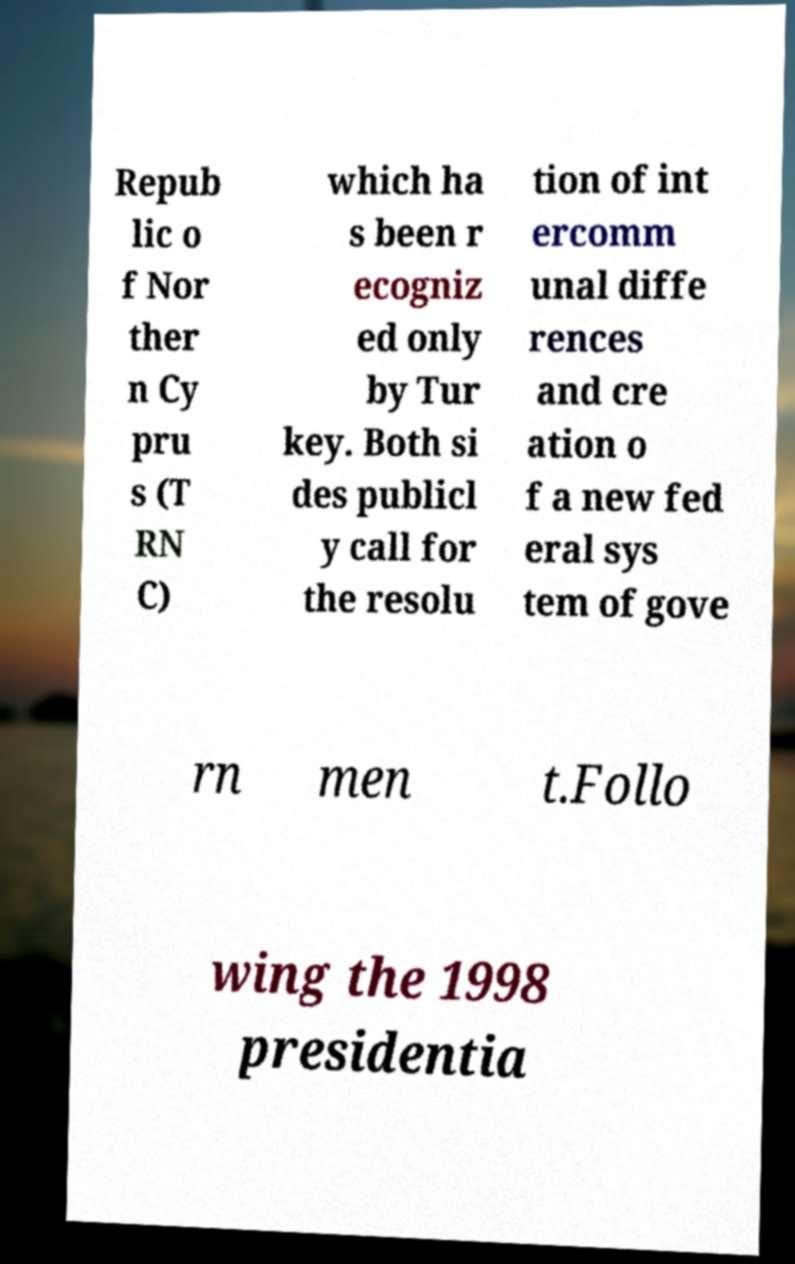For documentation purposes, I need the text within this image transcribed. Could you provide that? Repub lic o f Nor ther n Cy pru s (T RN C) which ha s been r ecogniz ed only by Tur key. Both si des publicl y call for the resolu tion of int ercomm unal diffe rences and cre ation o f a new fed eral sys tem of gove rn men t.Follo wing the 1998 presidentia 